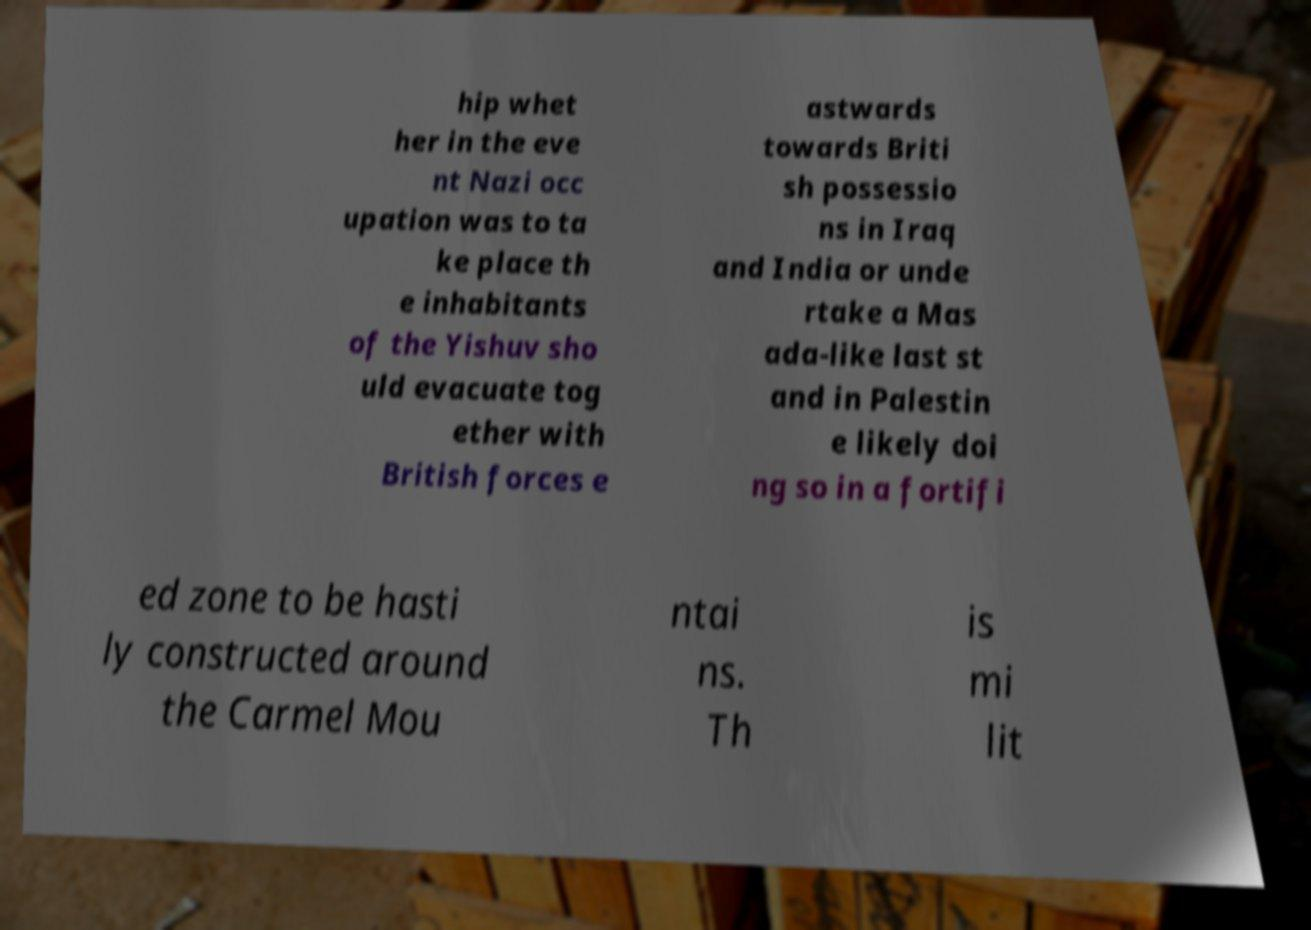I need the written content from this picture converted into text. Can you do that? hip whet her in the eve nt Nazi occ upation was to ta ke place th e inhabitants of the Yishuv sho uld evacuate tog ether with British forces e astwards towards Briti sh possessio ns in Iraq and India or unde rtake a Mas ada-like last st and in Palestin e likely doi ng so in a fortifi ed zone to be hasti ly constructed around the Carmel Mou ntai ns. Th is mi lit 